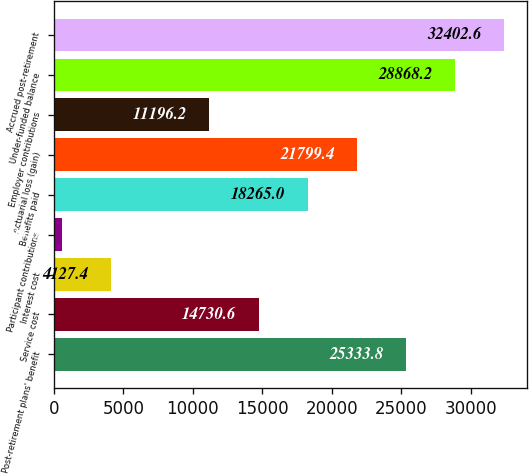Convert chart. <chart><loc_0><loc_0><loc_500><loc_500><bar_chart><fcel>Post-retirement plans' benefit<fcel>Service cost<fcel>Interest cost<fcel>Participant contributions<fcel>Benefits paid<fcel>Actuarial loss (gain)<fcel>Employer contributions<fcel>Under-funded balance<fcel>Accrued post-retirement<nl><fcel>25333.8<fcel>14730.6<fcel>4127.4<fcel>593<fcel>18265<fcel>21799.4<fcel>11196.2<fcel>28868.2<fcel>32402.6<nl></chart> 